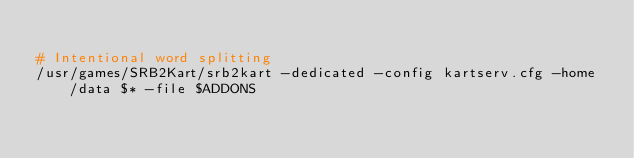Convert code to text. <code><loc_0><loc_0><loc_500><loc_500><_Bash_>
# Intentional word splitting
/usr/games/SRB2Kart/srb2kart -dedicated -config kartserv.cfg -home /data $* -file $ADDONS</code> 